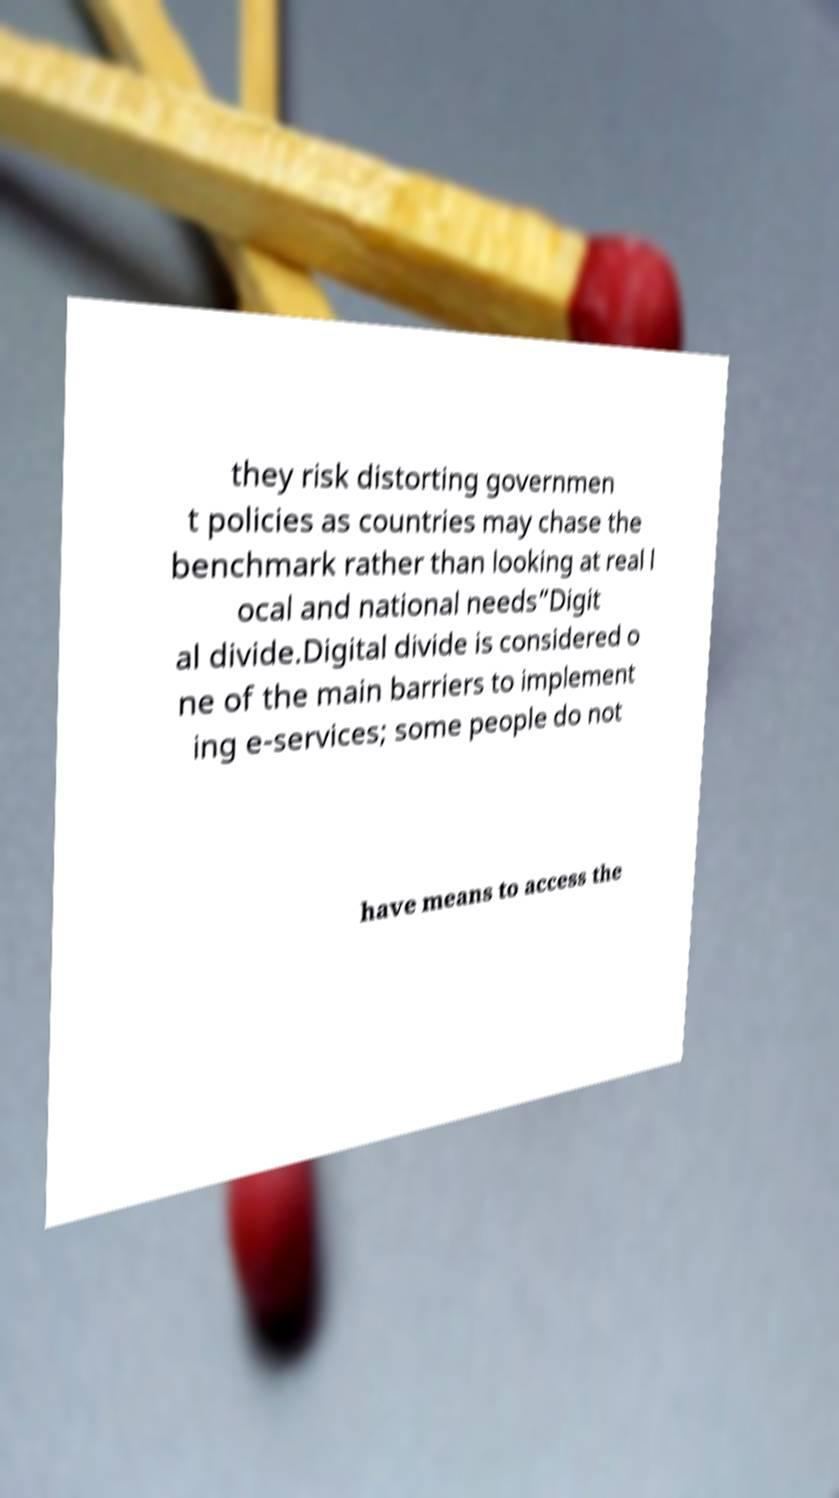I need the written content from this picture converted into text. Can you do that? they risk distorting governmen t policies as countries may chase the benchmark rather than looking at real l ocal and national needs”Digit al divide.Digital divide is considered o ne of the main barriers to implement ing e-services; some people do not have means to access the 